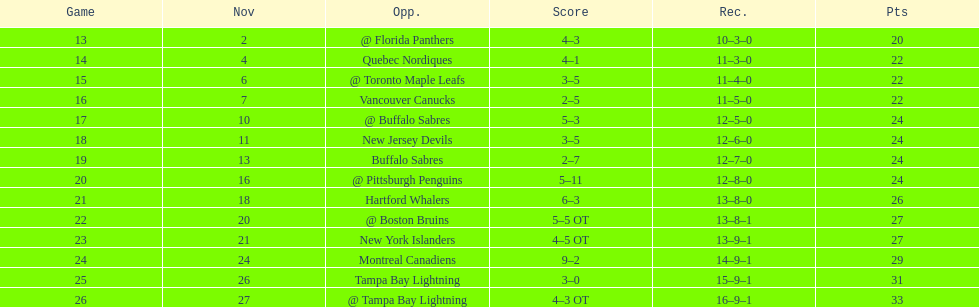What was the number of wins the philadelphia flyers had? 35. 